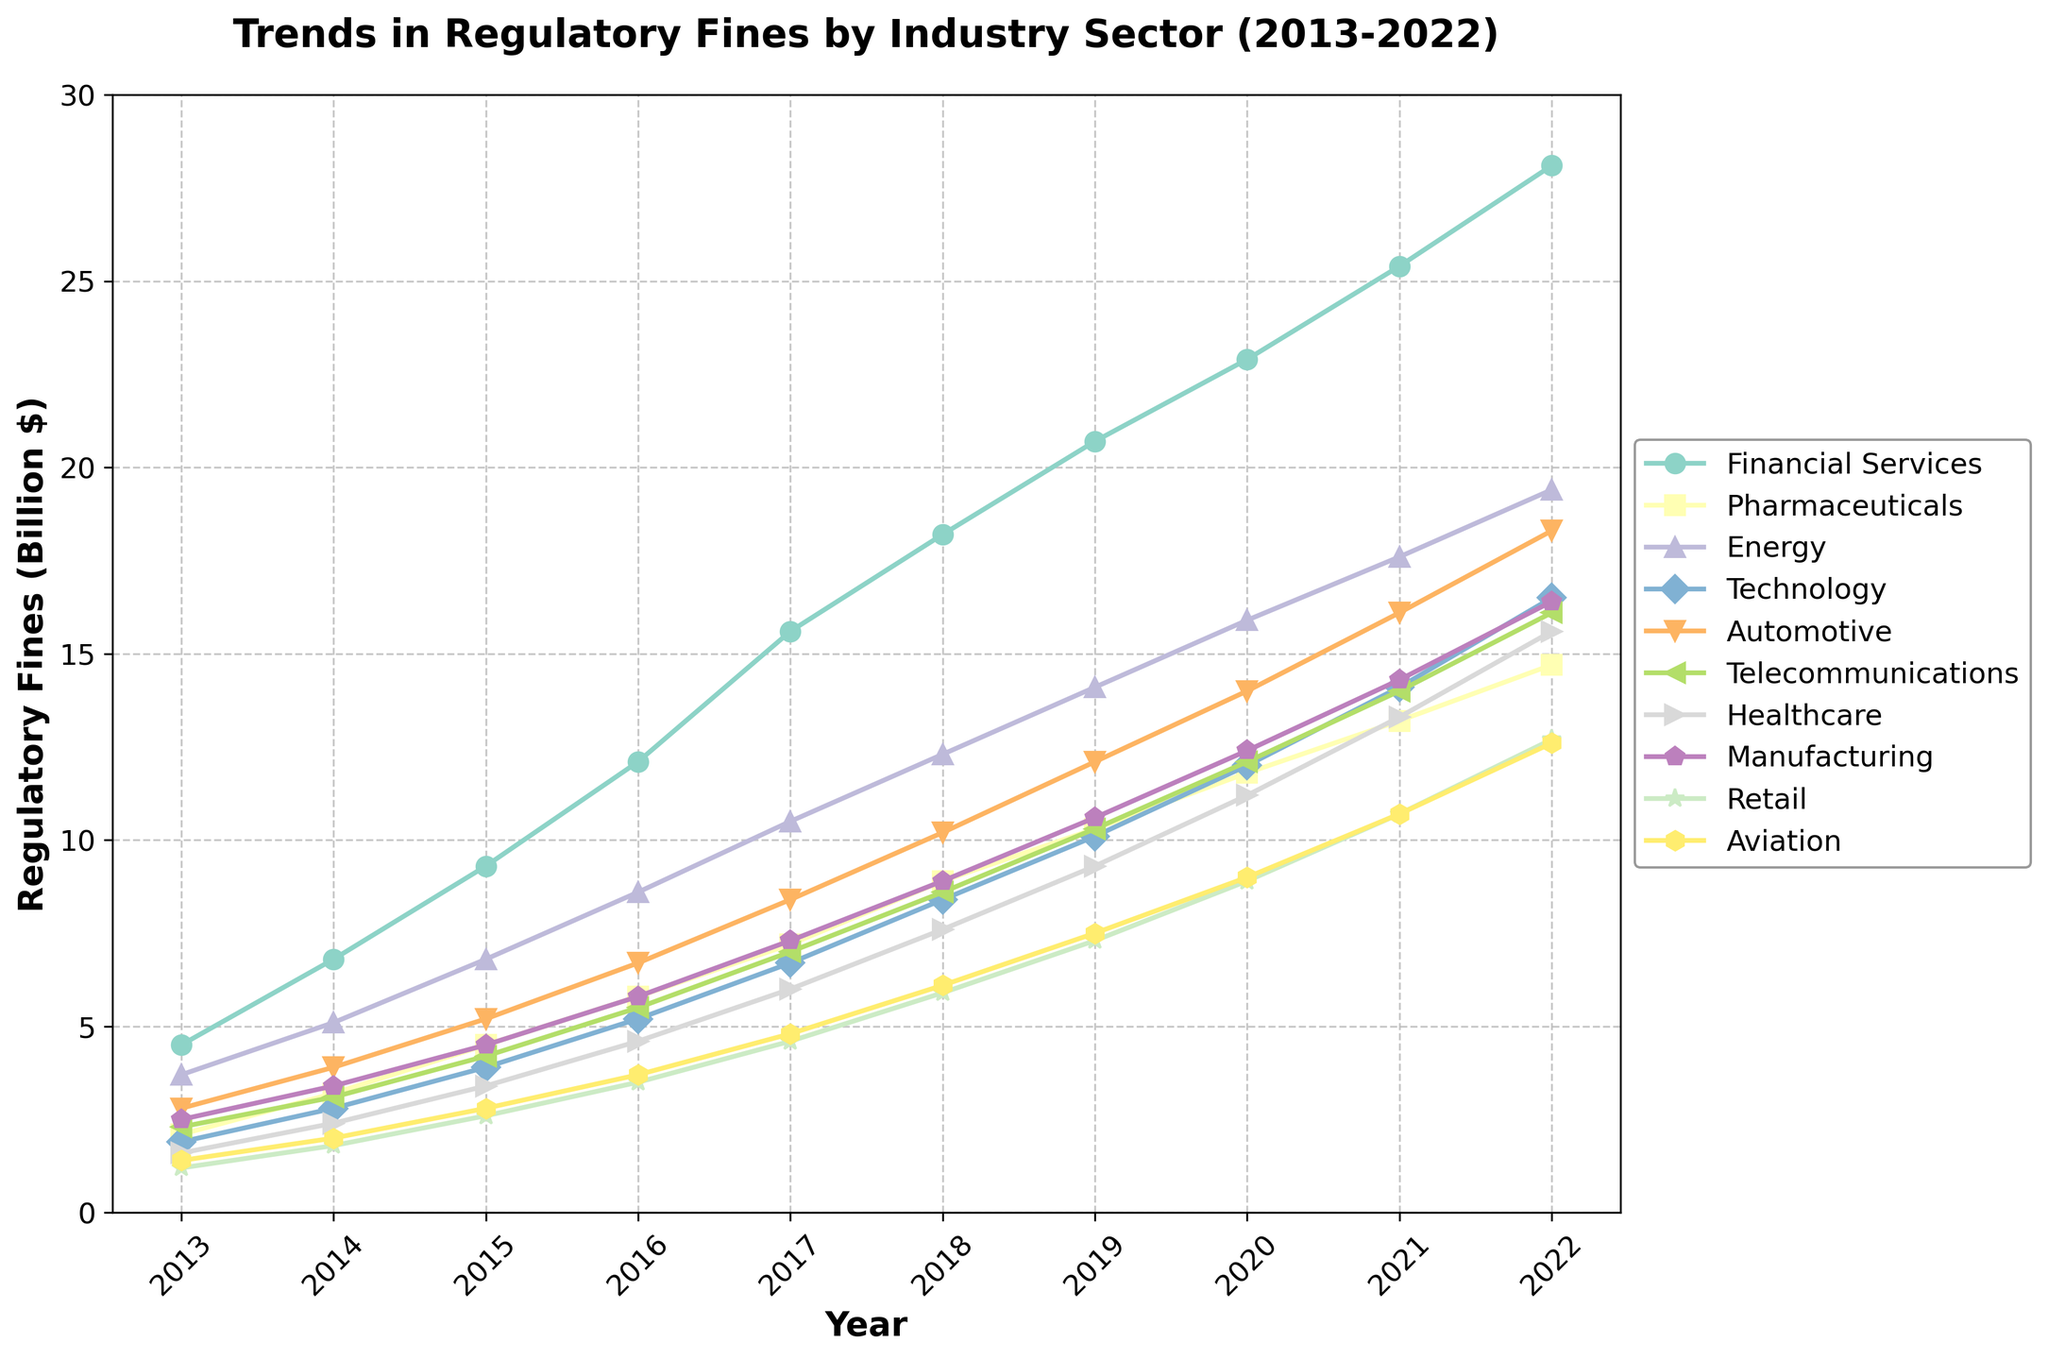What is the trend in regulatory fines for the Financial Services sector over the decade? From 2013 to 2022, the regulatory fines for the Financial Services sector have been increasing every year, starting from 4.5 billion dollars in 2013 to 28.1 billion dollars in 2022. This indicates a consistent upward trend without any decrease in fines throughout the decade.
Answer: Increasing Which industry sector shows the highest regulatory fines in 2022? By examining the y-axis position of each line in 2022, the Financial Services sector has the highest regulatory fines at 28.1 billion dollars.
Answer: Financial Services Compare the regulatory fines of the Technology sector in 2013 and 2022. The regulatory fines for the Technology sector were 1.9 billion dollars in 2013 and increased to 16.5 billion dollars in 2022. To compare, the fines rose by 14.6 billion dollars over the decade, showing significant growth.
Answer: Increased by 14.6 billion dollars Which industries experienced over 15 billion dollars in regulatory fines by 2022? The lines for Financial Services, Energy, Technology, Automotive, Telecommunications, and Healthcare all surpass the 15 billion dollar mark by 2022.
Answer: Financial Services, Energy, Technology, Automotive, Telecommunications, Healthcare Which two industries had the closest regulatory fines in 2022, and what were those fines? The fines for the Automotive and Telecommunications sectors in 2022 are both at 16.1 billion dollars, making them the closest to each other.
Answer: Automotive and Telecommunications, 16.1 billion dollars What is the overall trend in regulatory fines for the Healthcare sector from 2013-2022? The fines for the Healthcare sector have shown a steady increase from 1.6 billion dollars in 2013 to 15.6 billion dollars in 2022. This indicates a continuous, though gradual, rise in regulatory fines over the years.
Answer: Steady increase How much did the regulatory fines for the Energy sector change from 2021 to 2022? The fines increased from 17.6 billion dollars in 2021 to 19.4 billion dollars in 2022. The change can be calculated as 19.4 - 17.6 = 1.8 billion dollars.
Answer: 1.8 billion dollars Compare the trend lines of Retail and Aviation sectors. What can we infer about their regulatory fines? Both the Retail and Aviation sectors show an upward trend in their fines. However, Retail fines increased from 1.2 billion dollars in 2013 to 12.7 billion dollars in 2022, while Aviation fines increased from 1.4 billion dollars in 2013 to 12.6 billion dollars in 2022. Therefore, both sectors have similar growth patterns, though the Retail sector started slightly lower and ended slightly higher by 2022.
Answer: Similar upward trend, with Retail slightly higher in the end What is the average regulatory fine across all industries in 2017? First, sum the regulatory fines for all industries in 2017: 15.6 (Financial Services) + 7.2 (Pharmaceuticals) + 10.5 (Energy) + 6.7 (Technology) + 8.4 (Automotive) + 7.0 (Telecommunications) + 6.0 (Healthcare) + 7.3 (Manufacturing) + 4.6 (Retail) + 4.8 (Aviation) = 78.1 billion dollars. Then, divide by the 10 industries: 78.1 / 10 = 7.81 billion dollars.
Answer: 7.81 billion dollars 